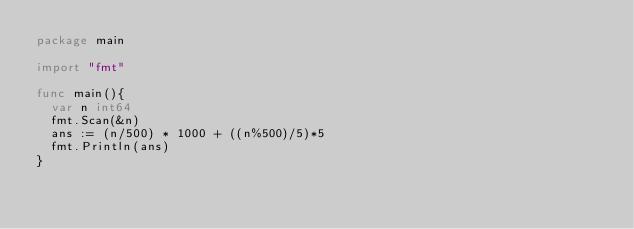Convert code to text. <code><loc_0><loc_0><loc_500><loc_500><_Go_>package main

import "fmt"

func main(){
  var n int64 
  fmt.Scan(&n)
  ans := (n/500) * 1000 + ((n%500)/5)*5
  fmt.Println(ans)  
}</code> 